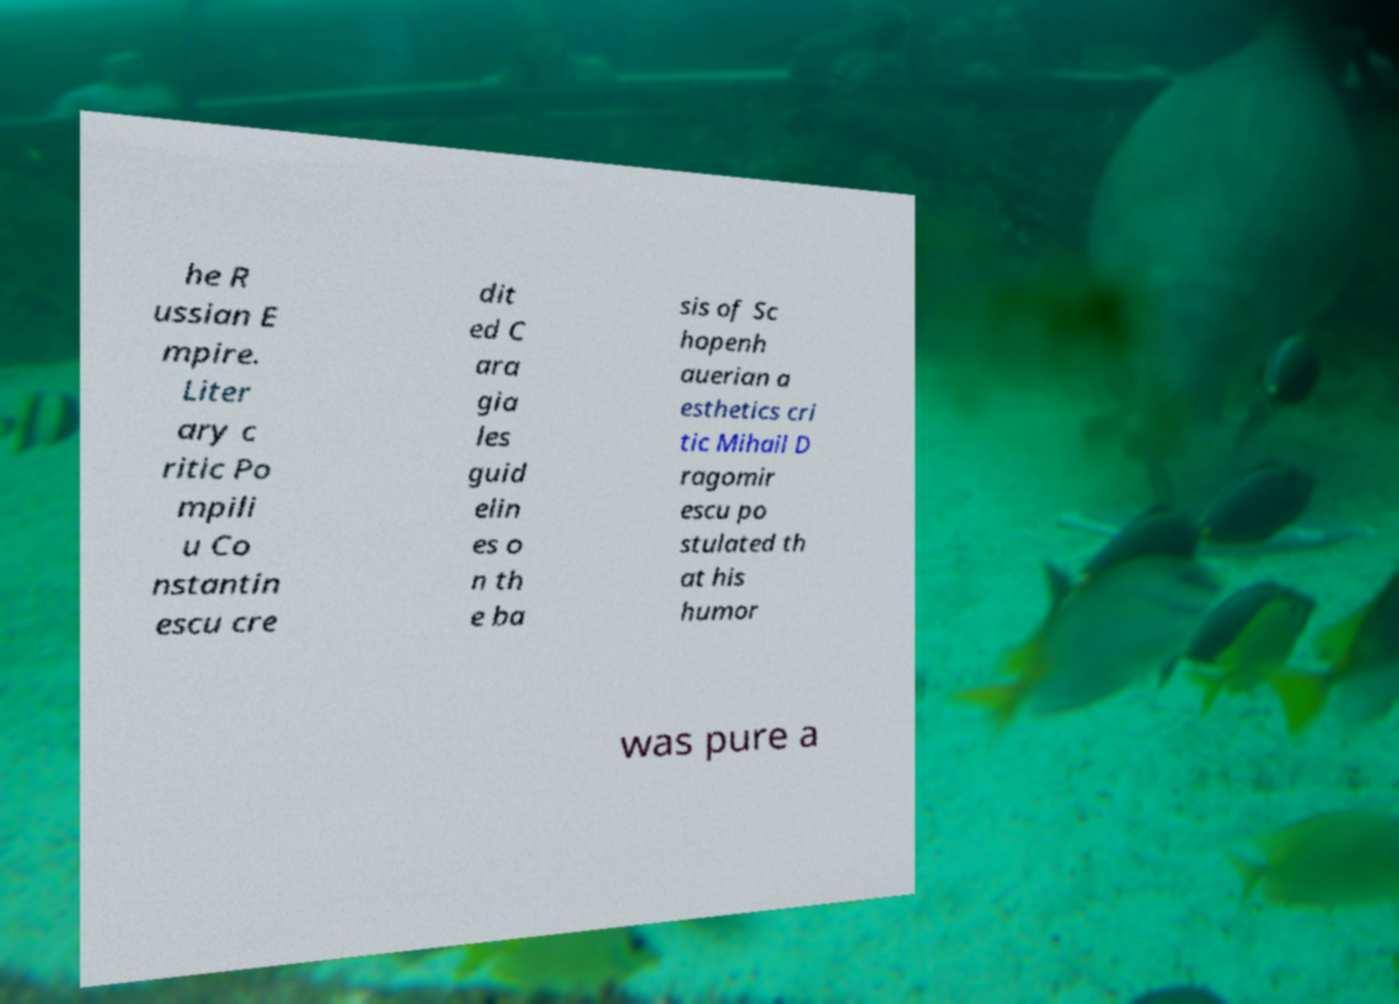For documentation purposes, I need the text within this image transcribed. Could you provide that? he R ussian E mpire. Liter ary c ritic Po mpili u Co nstantin escu cre dit ed C ara gia les guid elin es o n th e ba sis of Sc hopenh auerian a esthetics cri tic Mihail D ragomir escu po stulated th at his humor was pure a 